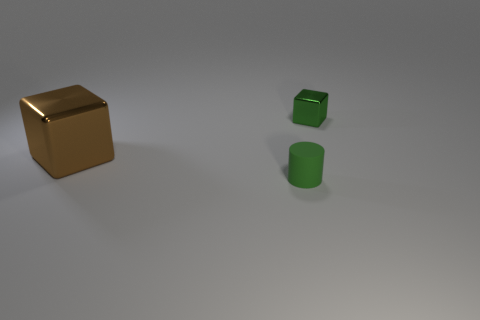Add 3 big cyan metallic objects. How many objects exist? 6 Subtract all blocks. How many objects are left? 1 Add 2 small matte objects. How many small matte objects exist? 3 Subtract 0 gray spheres. How many objects are left? 3 Subtract all big brown things. Subtract all tiny gray shiny cylinders. How many objects are left? 2 Add 3 tiny rubber cylinders. How many tiny rubber cylinders are left? 4 